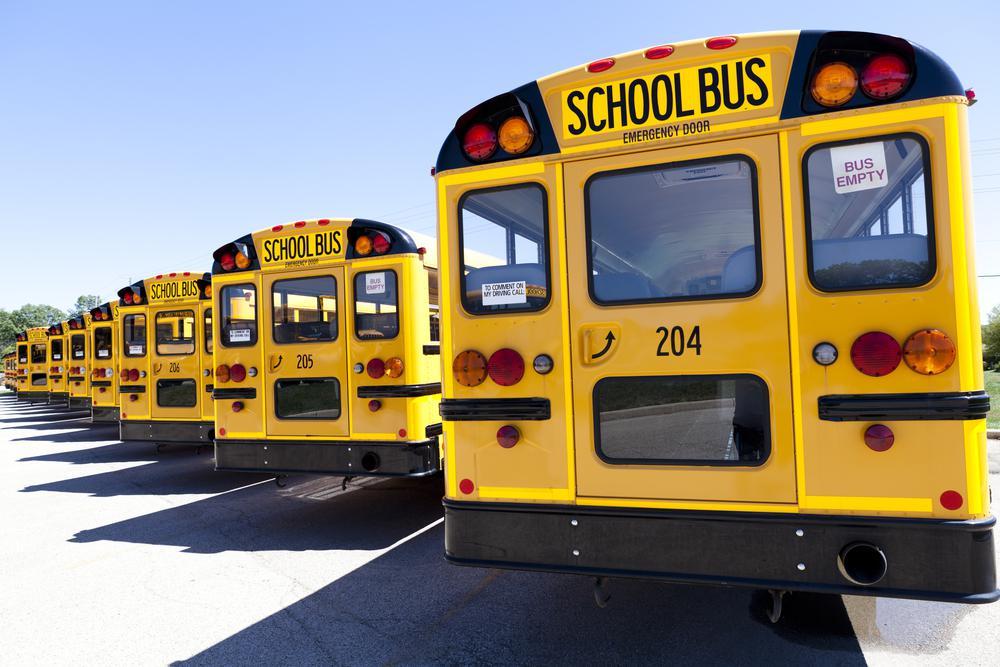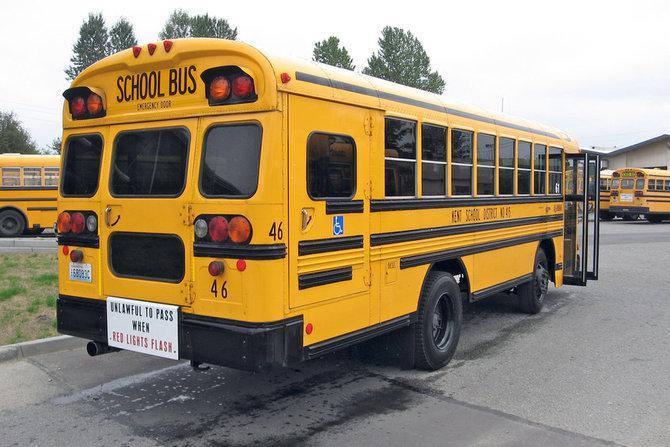The first image is the image on the left, the second image is the image on the right. Evaluate the accuracy of this statement regarding the images: "At least one image shows buses with forward-turned non-flat fronts parked side-by-side in a row and angled facing rightward.". Is it true? Answer yes or no. No. The first image is the image on the left, the second image is the image on the right. Evaluate the accuracy of this statement regarding the images: "Some buses have front license plates.". Is it true? Answer yes or no. No. 